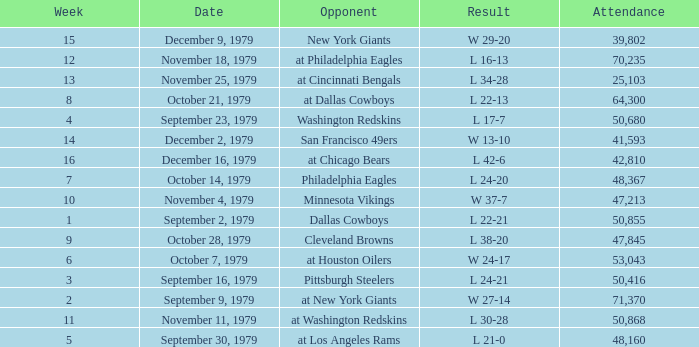What result in a week over 2 occurred with an attendance greater than 53,043 on November 18, 1979? L 16-13. 